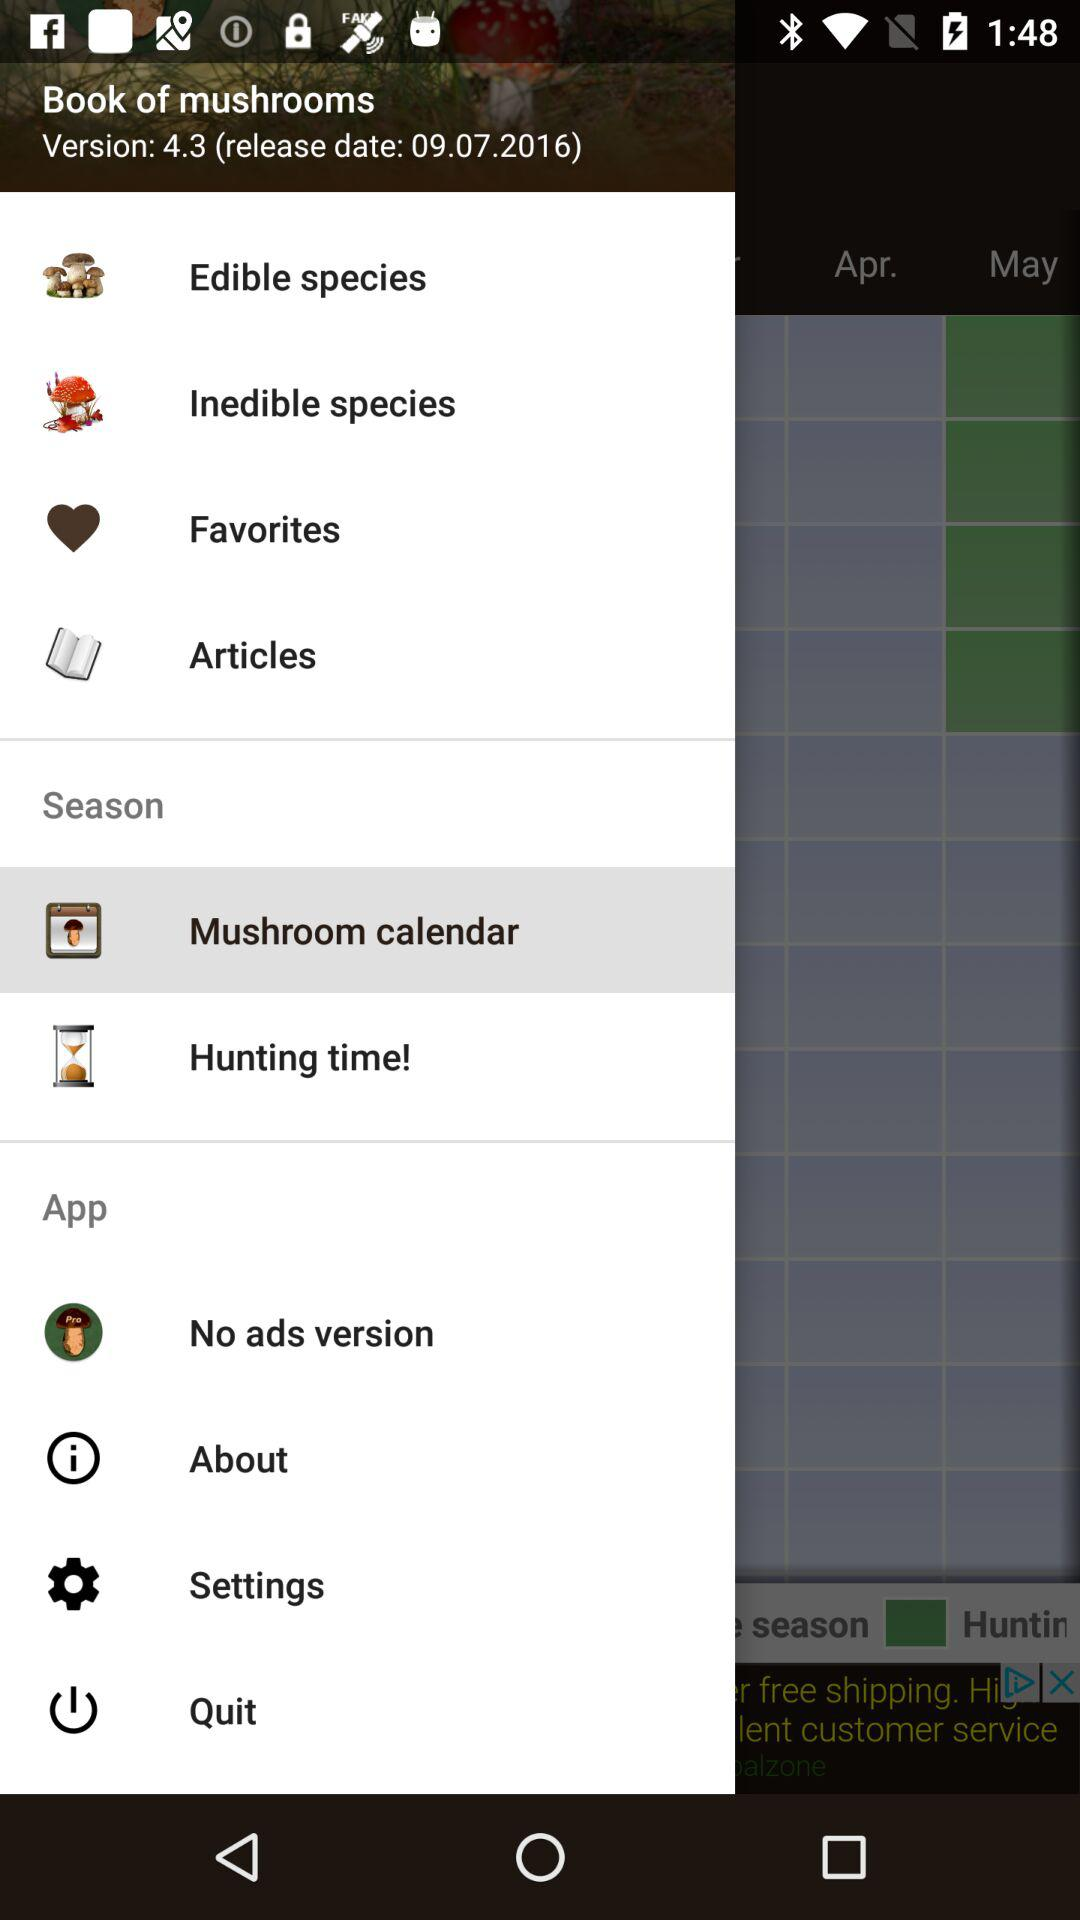What is the release date of the application? The release date of the application is September 7, 2016. 